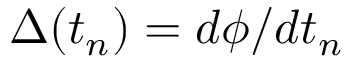Convert formula to latex. <formula><loc_0><loc_0><loc_500><loc_500>\Delta ( t _ { n } ) = d \phi / d t _ { n }</formula> 